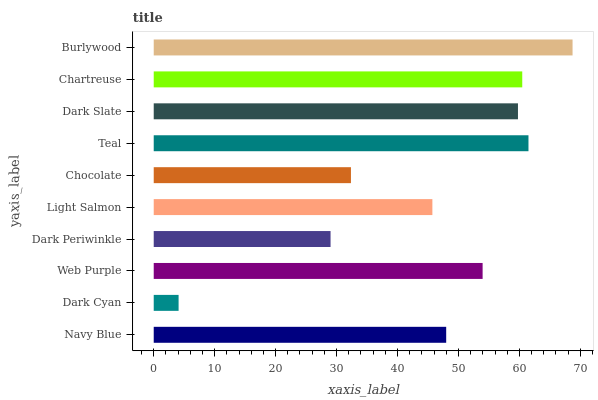Is Dark Cyan the minimum?
Answer yes or no. Yes. Is Burlywood the maximum?
Answer yes or no. Yes. Is Web Purple the minimum?
Answer yes or no. No. Is Web Purple the maximum?
Answer yes or no. No. Is Web Purple greater than Dark Cyan?
Answer yes or no. Yes. Is Dark Cyan less than Web Purple?
Answer yes or no. Yes. Is Dark Cyan greater than Web Purple?
Answer yes or no. No. Is Web Purple less than Dark Cyan?
Answer yes or no. No. Is Web Purple the high median?
Answer yes or no. Yes. Is Navy Blue the low median?
Answer yes or no. Yes. Is Light Salmon the high median?
Answer yes or no. No. Is Chartreuse the low median?
Answer yes or no. No. 